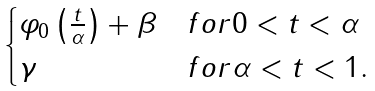<formula> <loc_0><loc_0><loc_500><loc_500>\begin{cases} \varphi _ { 0 } \left ( \frac { t } { \alpha } \right ) + \beta & f o r 0 < t < \alpha \\ \gamma & f o r \alpha < t < 1 . \end{cases}</formula> 